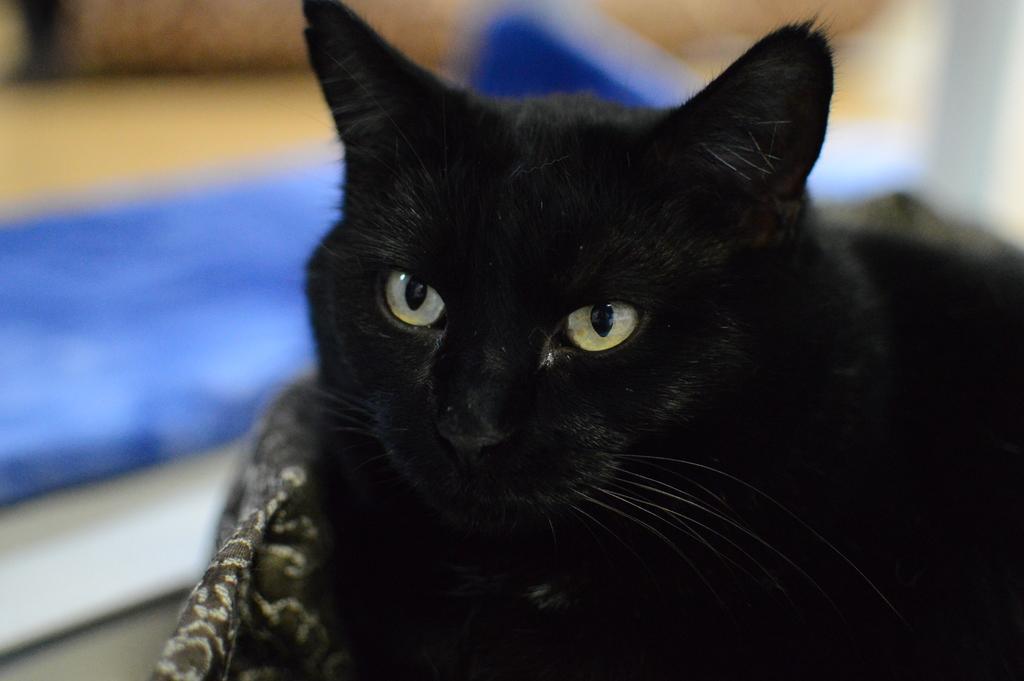Could you give a brief overview of what you see in this image? In this picture, we see a cat. It is in black color and it is looking at the camera. At the bottom of the picture, we see a blanket. Beside the cat, we see something in blue color. In the background, it is blurred. 